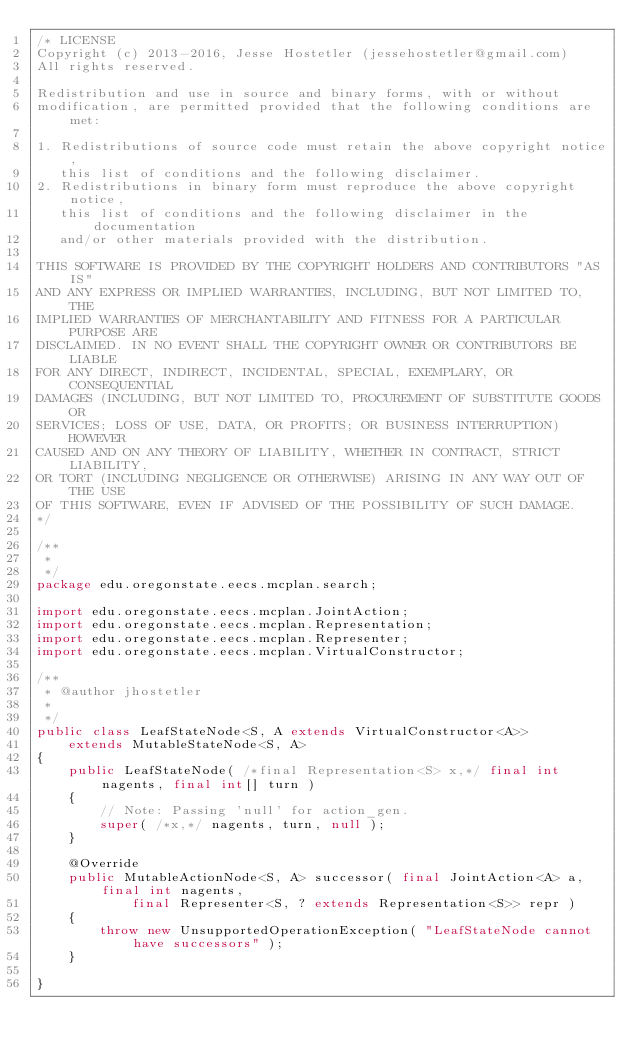Convert code to text. <code><loc_0><loc_0><loc_500><loc_500><_Java_>/* LICENSE
Copyright (c) 2013-2016, Jesse Hostetler (jessehostetler@gmail.com)
All rights reserved.

Redistribution and use in source and binary forms, with or without
modification, are permitted provided that the following conditions are met:

1. Redistributions of source code must retain the above copyright notice,
   this list of conditions and the following disclaimer.
2. Redistributions in binary form must reproduce the above copyright notice,
   this list of conditions and the following disclaimer in the documentation
   and/or other materials provided with the distribution.

THIS SOFTWARE IS PROVIDED BY THE COPYRIGHT HOLDERS AND CONTRIBUTORS "AS IS" 
AND ANY EXPRESS OR IMPLIED WARRANTIES, INCLUDING, BUT NOT LIMITED TO, THE
IMPLIED WARRANTIES OF MERCHANTABILITY AND FITNESS FOR A PARTICULAR PURPOSE ARE
DISCLAIMED. IN NO EVENT SHALL THE COPYRIGHT OWNER OR CONTRIBUTORS BE LIABLE
FOR ANY DIRECT, INDIRECT, INCIDENTAL, SPECIAL, EXEMPLARY, OR CONSEQUENTIAL
DAMAGES (INCLUDING, BUT NOT LIMITED TO, PROCUREMENT OF SUBSTITUTE GOODS OR
SERVICES; LOSS OF USE, DATA, OR PROFITS; OR BUSINESS INTERRUPTION) HOWEVER
CAUSED AND ON ANY THEORY OF LIABILITY, WHETHER IN CONTRACT, STRICT LIABILITY,
OR TORT (INCLUDING NEGLIGENCE OR OTHERWISE) ARISING IN ANY WAY OUT OF THE USE
OF THIS SOFTWARE, EVEN IF ADVISED OF THE POSSIBILITY OF SUCH DAMAGE.
*/

/**
 * 
 */
package edu.oregonstate.eecs.mcplan.search;

import edu.oregonstate.eecs.mcplan.JointAction;
import edu.oregonstate.eecs.mcplan.Representation;
import edu.oregonstate.eecs.mcplan.Representer;
import edu.oregonstate.eecs.mcplan.VirtualConstructor;

/**
 * @author jhostetler
 *
 */
public class LeafStateNode<S, A extends VirtualConstructor<A>>
	extends MutableStateNode<S, A>
{
	public LeafStateNode( /*final Representation<S> x,*/ final int nagents, final int[] turn )
	{
		// Note: Passing 'null' for action_gen.
		super( /*x,*/ nagents, turn, null );
	}

	@Override
	public MutableActionNode<S, A> successor( final JointAction<A> a, final int nagents,
			final Representer<S, ? extends Representation<S>> repr )
	{
		throw new UnsupportedOperationException( "LeafStateNode cannot have successors" );
	}

}
</code> 